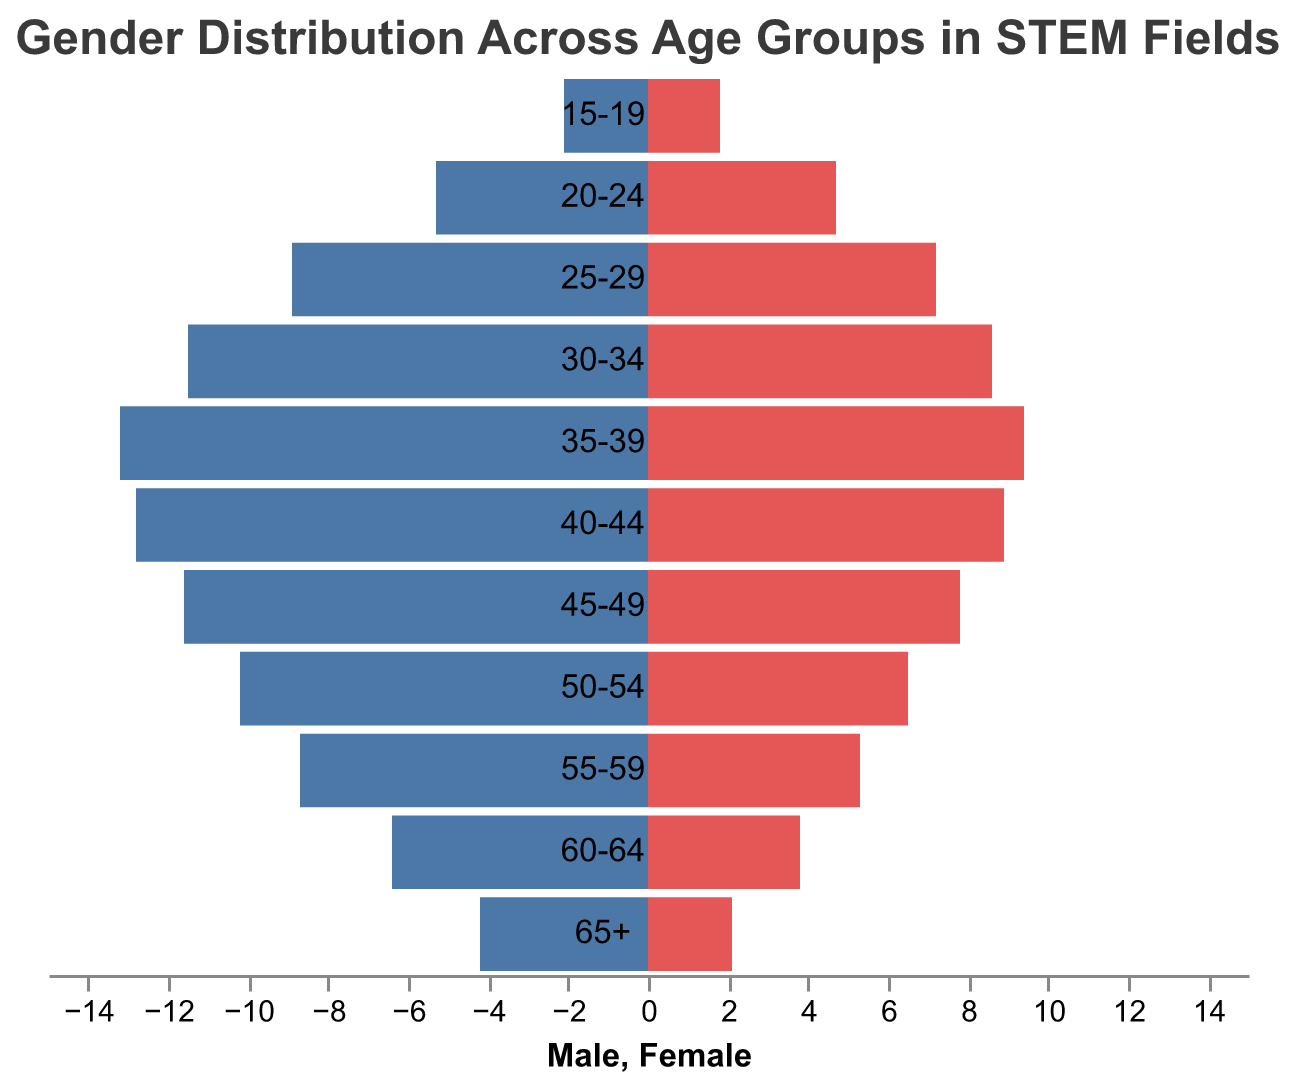What's the title of the figure? The title of the figure appears at the top and is labeled "Gender Distribution Across Age Groups in STEM Fields".
Answer: Gender Distribution Across Age Groups in STEM Fields Which age group has the highest number of males? The age group with the highest number of males is indicated by the longest bar on the male side of the population pyramid. We see that the 35-39 age group has the highest value at 13.2.
Answer: 35-39 What is the percentage difference between males and females in the 30-34 age group? To find the percentage difference, calculate the absolute difference between the male and female values, divide by the average, and multiply by 100. The values are 11.5 (male) and 8.6 (female). Absolute difference = 11.5 - 8.6 = 2.9. Average = (11.5 + 8.6) / 2 = 10.05. Percentage difference = (2.9 / 10.05) * 100 ≈ 28.86%.
Answer: 28.86% Which age group has the closest male-to-female ratio? To identify the age group with the closest male-to-female ratio, compare the values for all the age groups to find the smallest difference. The 15-19 age group has males at 2.1 and females at 1.8, resulting in a difference of 0.3, which is the smallest among all age groups.
Answer: 15-19 How many age groups have more than 10% males in STEM fields? To determine the number of age groups with more than 10% males, count the age groups with male values above 10%. The age groups 30-34 (11.5), 35-39 (13.2), 40-44 (12.8), 45-49 (11.6), and 50-54 (10.2) fit this criterion.
Answer: 5 What is the total number of females across all age groups? Sum the female values for all age groups. The values are: 1.8 + 4.7 + 7.2 + 8.6 + 9.4 + 8.9 + 7.8 + 6.5 + 5.3 + 3.8 + 2.1 = 66.1.
Answer: 66.1 Compare the number of males in the 45-49 age group with the number of females in the 35-39 age group. The number of males in the 45-49 age group is 11.6, while the number of females in the 35-39 age group is 9.4.
Answer: 11.6 is greater than 9.4 Which age group shows the largest gender disparity in STEM fields? To determine the largest gender disparity, calculate the absolute difference between the male and female values for each age group. The largest difference appears in the 35-39 age group, where males number 13.2 and females number 9.4, resulting in a difference of 3.8.
Answer: 35-39 Is there any age group where the number of females is greater than the number of males? Reviewing all age groups, we see that in all age groups the number of males is higher than females, indicating no age group where females surpass males.
Answer: No 